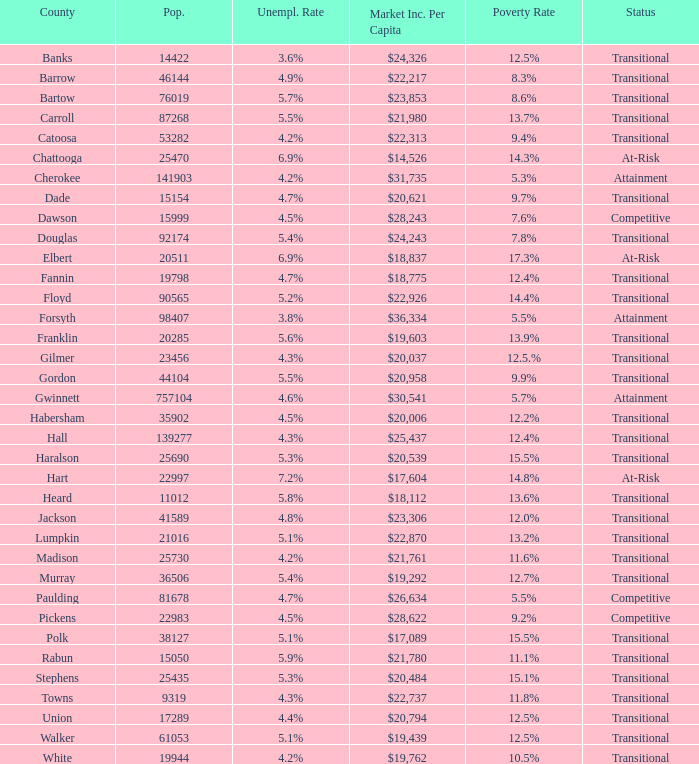What is the unemployment rate for the county with a market income per capita of $20,958? 1.0. 